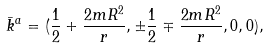Convert formula to latex. <formula><loc_0><loc_0><loc_500><loc_500>\bar { k } ^ { a } = ( \frac { 1 } { 2 } + \frac { 2 m R ^ { 2 } } { r } , \pm \frac { 1 } { 2 } \mp \frac { 2 m R ^ { 2 } } { r } , 0 , 0 ) ,</formula> 